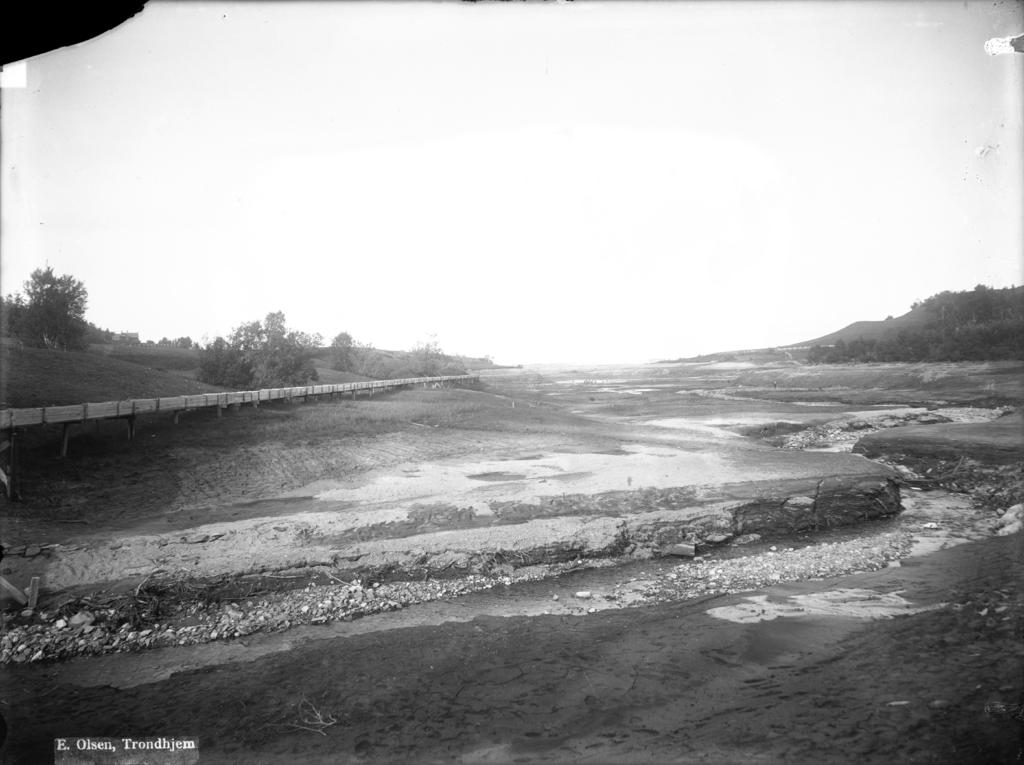What structure can be seen in the image? There is a bridge in the image. What is visible beneath the bridge? The ground is visible in the image. What type of vegetation is present in the image? There are trees and plants in the image. What type of natural landscape can be seen in the image? There are hills in the image. What is visible above the bridge? The sky is visible in the image. How many spiders are crawling on the bridge in the image? There are no spiders present on the bridge in the image. What type of memory can be seen in the image? There is no memory present in the image; it features a bridge, ground, trees, plants, hills, and the sky. 